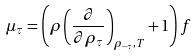Convert formula to latex. <formula><loc_0><loc_0><loc_500><loc_500>\mu _ { \tau } = \left ( \rho \left ( \frac { \partial } { \partial \rho _ { \tau } } \right ) _ { \rho _ { - \tau } , T } + 1 \right ) f</formula> 